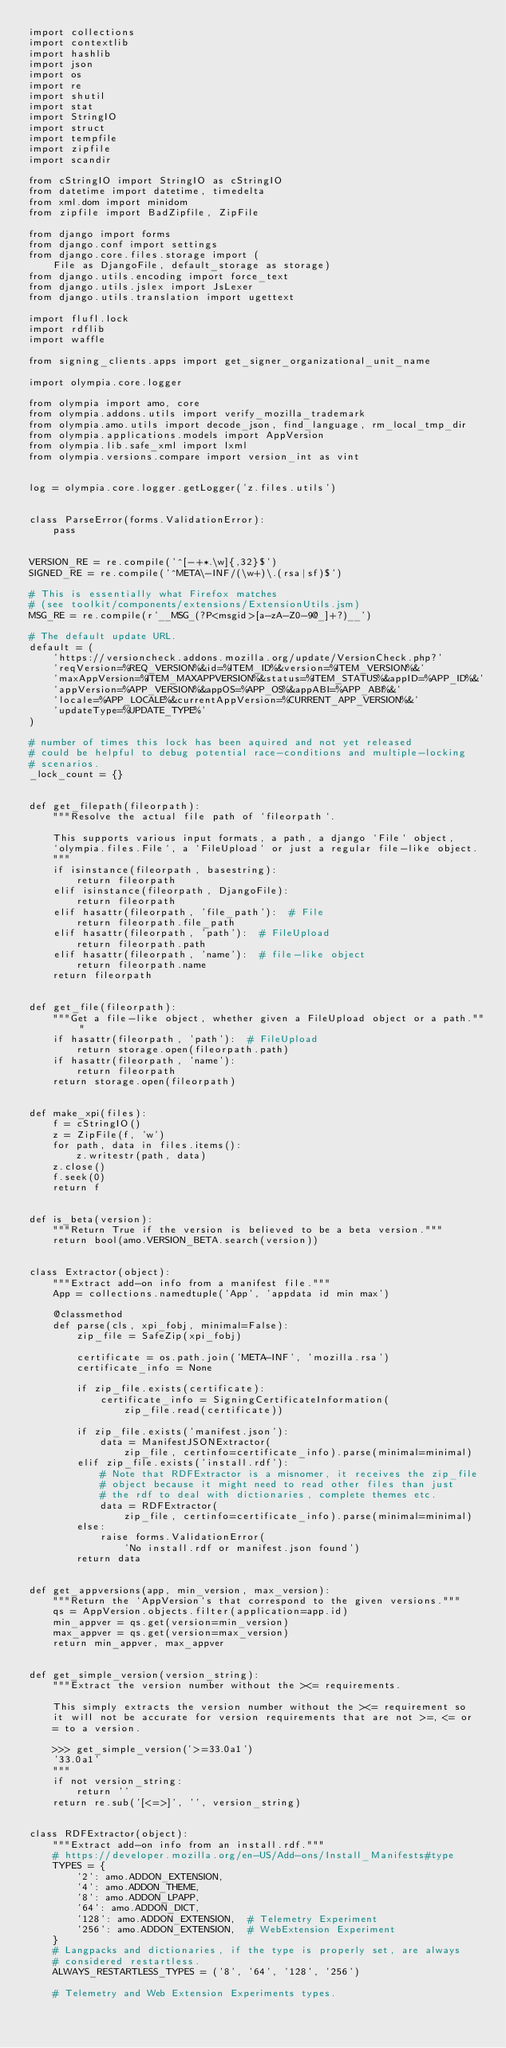<code> <loc_0><loc_0><loc_500><loc_500><_Python_>import collections
import contextlib
import hashlib
import json
import os
import re
import shutil
import stat
import StringIO
import struct
import tempfile
import zipfile
import scandir

from cStringIO import StringIO as cStringIO
from datetime import datetime, timedelta
from xml.dom import minidom
from zipfile import BadZipfile, ZipFile

from django import forms
from django.conf import settings
from django.core.files.storage import (
    File as DjangoFile, default_storage as storage)
from django.utils.encoding import force_text
from django.utils.jslex import JsLexer
from django.utils.translation import ugettext

import flufl.lock
import rdflib
import waffle

from signing_clients.apps import get_signer_organizational_unit_name

import olympia.core.logger

from olympia import amo, core
from olympia.addons.utils import verify_mozilla_trademark
from olympia.amo.utils import decode_json, find_language, rm_local_tmp_dir
from olympia.applications.models import AppVersion
from olympia.lib.safe_xml import lxml
from olympia.versions.compare import version_int as vint


log = olympia.core.logger.getLogger('z.files.utils')


class ParseError(forms.ValidationError):
    pass


VERSION_RE = re.compile('^[-+*.\w]{,32}$')
SIGNED_RE = re.compile('^META\-INF/(\w+)\.(rsa|sf)$')

# This is essentially what Firefox matches
# (see toolkit/components/extensions/ExtensionUtils.jsm)
MSG_RE = re.compile(r'__MSG_(?P<msgid>[a-zA-Z0-9@_]+?)__')

# The default update URL.
default = (
    'https://versioncheck.addons.mozilla.org/update/VersionCheck.php?'
    'reqVersion=%REQ_VERSION%&id=%ITEM_ID%&version=%ITEM_VERSION%&'
    'maxAppVersion=%ITEM_MAXAPPVERSION%&status=%ITEM_STATUS%&appID=%APP_ID%&'
    'appVersion=%APP_VERSION%&appOS=%APP_OS%&appABI=%APP_ABI%&'
    'locale=%APP_LOCALE%&currentAppVersion=%CURRENT_APP_VERSION%&'
    'updateType=%UPDATE_TYPE%'
)

# number of times this lock has been aquired and not yet released
# could be helpful to debug potential race-conditions and multiple-locking
# scenarios.
_lock_count = {}


def get_filepath(fileorpath):
    """Resolve the actual file path of `fileorpath`.

    This supports various input formats, a path, a django `File` object,
    `olympia.files.File`, a `FileUpload` or just a regular file-like object.
    """
    if isinstance(fileorpath, basestring):
        return fileorpath
    elif isinstance(fileorpath, DjangoFile):
        return fileorpath
    elif hasattr(fileorpath, 'file_path'):  # File
        return fileorpath.file_path
    elif hasattr(fileorpath, 'path'):  # FileUpload
        return fileorpath.path
    elif hasattr(fileorpath, 'name'):  # file-like object
        return fileorpath.name
    return fileorpath


def get_file(fileorpath):
    """Get a file-like object, whether given a FileUpload object or a path."""
    if hasattr(fileorpath, 'path'):  # FileUpload
        return storage.open(fileorpath.path)
    if hasattr(fileorpath, 'name'):
        return fileorpath
    return storage.open(fileorpath)


def make_xpi(files):
    f = cStringIO()
    z = ZipFile(f, 'w')
    for path, data in files.items():
        z.writestr(path, data)
    z.close()
    f.seek(0)
    return f


def is_beta(version):
    """Return True if the version is believed to be a beta version."""
    return bool(amo.VERSION_BETA.search(version))


class Extractor(object):
    """Extract add-on info from a manifest file."""
    App = collections.namedtuple('App', 'appdata id min max')

    @classmethod
    def parse(cls, xpi_fobj, minimal=False):
        zip_file = SafeZip(xpi_fobj)

        certificate = os.path.join('META-INF', 'mozilla.rsa')
        certificate_info = None

        if zip_file.exists(certificate):
            certificate_info = SigningCertificateInformation(
                zip_file.read(certificate))

        if zip_file.exists('manifest.json'):
            data = ManifestJSONExtractor(
                zip_file, certinfo=certificate_info).parse(minimal=minimal)
        elif zip_file.exists('install.rdf'):
            # Note that RDFExtractor is a misnomer, it receives the zip_file
            # object because it might need to read other files than just
            # the rdf to deal with dictionaries, complete themes etc.
            data = RDFExtractor(
                zip_file, certinfo=certificate_info).parse(minimal=minimal)
        else:
            raise forms.ValidationError(
                'No install.rdf or manifest.json found')
        return data


def get_appversions(app, min_version, max_version):
    """Return the `AppVersion`s that correspond to the given versions."""
    qs = AppVersion.objects.filter(application=app.id)
    min_appver = qs.get(version=min_version)
    max_appver = qs.get(version=max_version)
    return min_appver, max_appver


def get_simple_version(version_string):
    """Extract the version number without the ><= requirements.

    This simply extracts the version number without the ><= requirement so
    it will not be accurate for version requirements that are not >=, <= or
    = to a version.

    >>> get_simple_version('>=33.0a1')
    '33.0a1'
    """
    if not version_string:
        return ''
    return re.sub('[<=>]', '', version_string)


class RDFExtractor(object):
    """Extract add-on info from an install.rdf."""
    # https://developer.mozilla.org/en-US/Add-ons/Install_Manifests#type
    TYPES = {
        '2': amo.ADDON_EXTENSION,
        '4': amo.ADDON_THEME,
        '8': amo.ADDON_LPAPP,
        '64': amo.ADDON_DICT,
        '128': amo.ADDON_EXTENSION,  # Telemetry Experiment
        '256': amo.ADDON_EXTENSION,  # WebExtension Experiment
    }
    # Langpacks and dictionaries, if the type is properly set, are always
    # considered restartless.
    ALWAYS_RESTARTLESS_TYPES = ('8', '64', '128', '256')

    # Telemetry and Web Extension Experiments types.</code> 